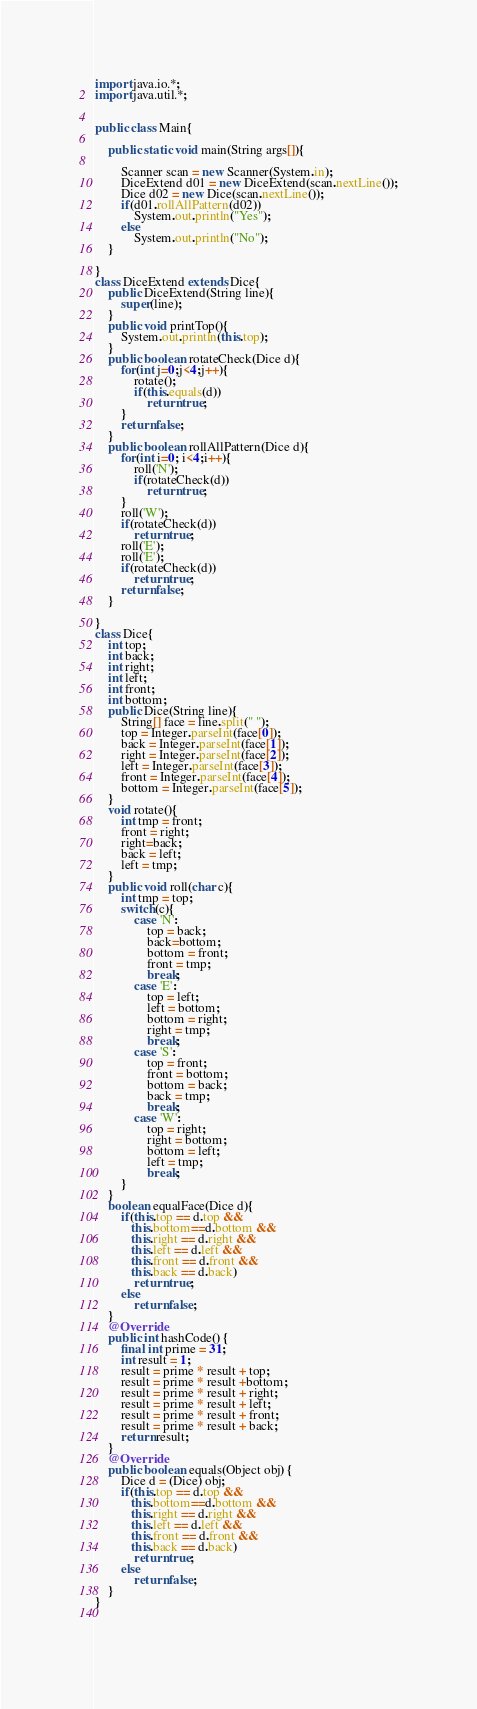Convert code to text. <code><loc_0><loc_0><loc_500><loc_500><_Java_>import java.io.*;
import java.util.*;


public class Main{ 

	public static void main(String args[]){
		
		Scanner scan = new Scanner(System.in);
		DiceExtend d01 = new DiceExtend(scan.nextLine());
		Dice d02 = new Dice(scan.nextLine());
		if(d01.rollAllPattern(d02))
			System.out.println("Yes");
		else
			System.out.println("No");
	}

}
class DiceExtend extends Dice{
	public DiceExtend(String line){
		super(line);
	}
	public void printTop(){
		System.out.println(this.top);
	}
	public boolean rotateCheck(Dice d){
		for(int j=0;j<4;j++){
			rotate();
			if(this.equals(d))
				return true;
		}
		return false;
	}
	public boolean rollAllPattern(Dice d){
		for(int i=0; i<4;i++){
			roll('N');
			if(rotateCheck(d))
				return true;
		}
		roll('W');
		if(rotateCheck(d))
			return true;		
		roll('E');
		roll('E');		
		if(rotateCheck(d))
			return true;		
		return false;				
	}
	
}
class Dice{
	int top;
	int back;
	int right;
	int left;
	int front;
	int bottom;
	public Dice(String line){
		String[] face = line.split(" ");
		top = Integer.parseInt(face[0]);
		back = Integer.parseInt(face[1]);
		right = Integer.parseInt(face[2]);		
		left = Integer.parseInt(face[3]);
		front = Integer.parseInt(face[4]);
		bottom = Integer.parseInt(face[5]);
	}
	void rotate(){
		int tmp = front;
		front = right;
		right=back;
		back = left;
		left = tmp;
	}
	public void roll(char c){
		int tmp = top;
		switch(c){
			case 'N':
				top = back;
				back=bottom;
				bottom = front;
				front = tmp;
				break;
			case 'E':
				top = left;
				left = bottom;
				bottom = right;
				right = tmp;
				break;
			case 'S':
				top = front;
				front = bottom;
				bottom = back;
				back = tmp;
				break;
			case 'W':
				top = right;
				right = bottom;
				bottom = left;
				left = tmp;
				break;
		}
	}
	boolean equalFace(Dice d){
		if(this.top == d.top && 
		   this.bottom==d.bottom &&
		   this.right == d.right &&
		   this.left == d.left &&
		   this.front == d.front &&
		   this.back == d.back)
			return true;
		else
			return false;
	}
	@Override
	public int hashCode() {
	    final int prime = 31;
	    int result = 1;
	    result = prime * result + top;
	    result = prime * result +bottom;
	    result = prime * result + right;
	    result = prime * result + left;
	    result = prime * result + front;
	    result = prime * result + back;
	    return result;
    }
	@Override
	public boolean equals(Object obj) {
		Dice d = (Dice) obj;
		if(this.top == d.top && 
		   this.bottom==d.bottom &&
		   this.right == d.right &&
		   this.left == d.left &&
		   this.front == d.front &&
		   this.back == d.back)
			return true;
		else
			return false;
	}
}	
	
	</code> 